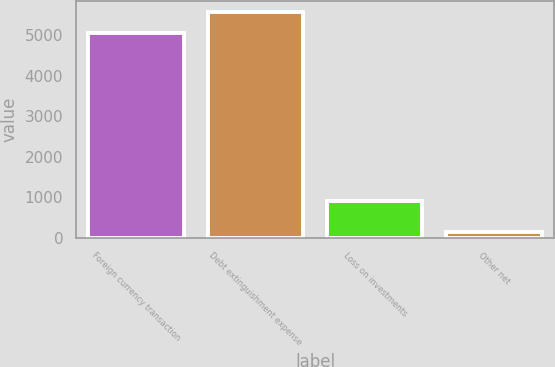Convert chart. <chart><loc_0><loc_0><loc_500><loc_500><bar_chart><fcel>Foreign currency transaction<fcel>Debt extinguishment expense<fcel>Loss on investments<fcel>Other net<nl><fcel>5045<fcel>5573.3<fcel>901<fcel>148<nl></chart> 